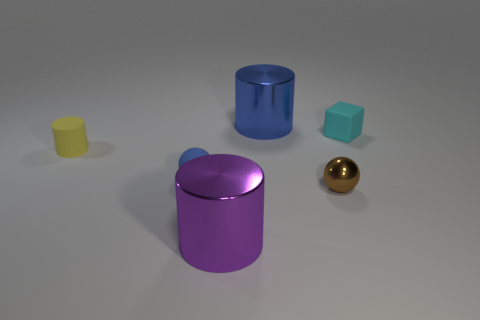Subtract all metal cylinders. How many cylinders are left? 1 Add 1 large purple metal objects. How many objects exist? 7 Subtract all purple cylinders. How many cylinders are left? 2 Subtract all red cubes. How many red spheres are left? 0 Add 5 blue things. How many blue things are left? 7 Add 6 large purple metallic objects. How many large purple metallic objects exist? 7 Subtract 0 green balls. How many objects are left? 6 Subtract all blocks. How many objects are left? 5 Subtract 1 blocks. How many blocks are left? 0 Subtract all brown cylinders. Subtract all blue cubes. How many cylinders are left? 3 